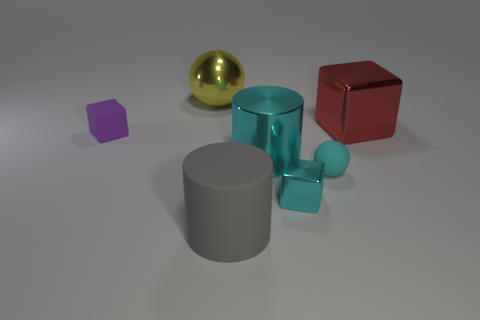Are there any other things that have the same color as the small metal object?
Provide a short and direct response. Yes. There is a object that is behind the tiny purple block and left of the large red thing; what shape is it?
Keep it short and to the point. Sphere. What size is the metallic cube that is behind the cyan matte thing?
Offer a terse response. Large. There is a ball that is in front of the large object to the left of the large gray matte cylinder; what number of small cyan spheres are behind it?
Ensure brevity in your answer.  0. There is a tiny cyan matte sphere; are there any tiny cyan metal objects behind it?
Keep it short and to the point. No. What number of other things are the same size as the matte block?
Make the answer very short. 2. What is the object that is in front of the cyan rubber thing and behind the gray thing made of?
Your response must be concise. Metal. There is a big cyan metallic thing that is on the right side of the tiny purple cube; is its shape the same as the rubber thing that is left of the gray matte thing?
Offer a very short reply. No. Is there any other thing that has the same material as the large sphere?
Offer a terse response. Yes. What shape is the gray matte thing that is left of the shiny cube behind the matte ball to the left of the large red metal block?
Ensure brevity in your answer.  Cylinder. 